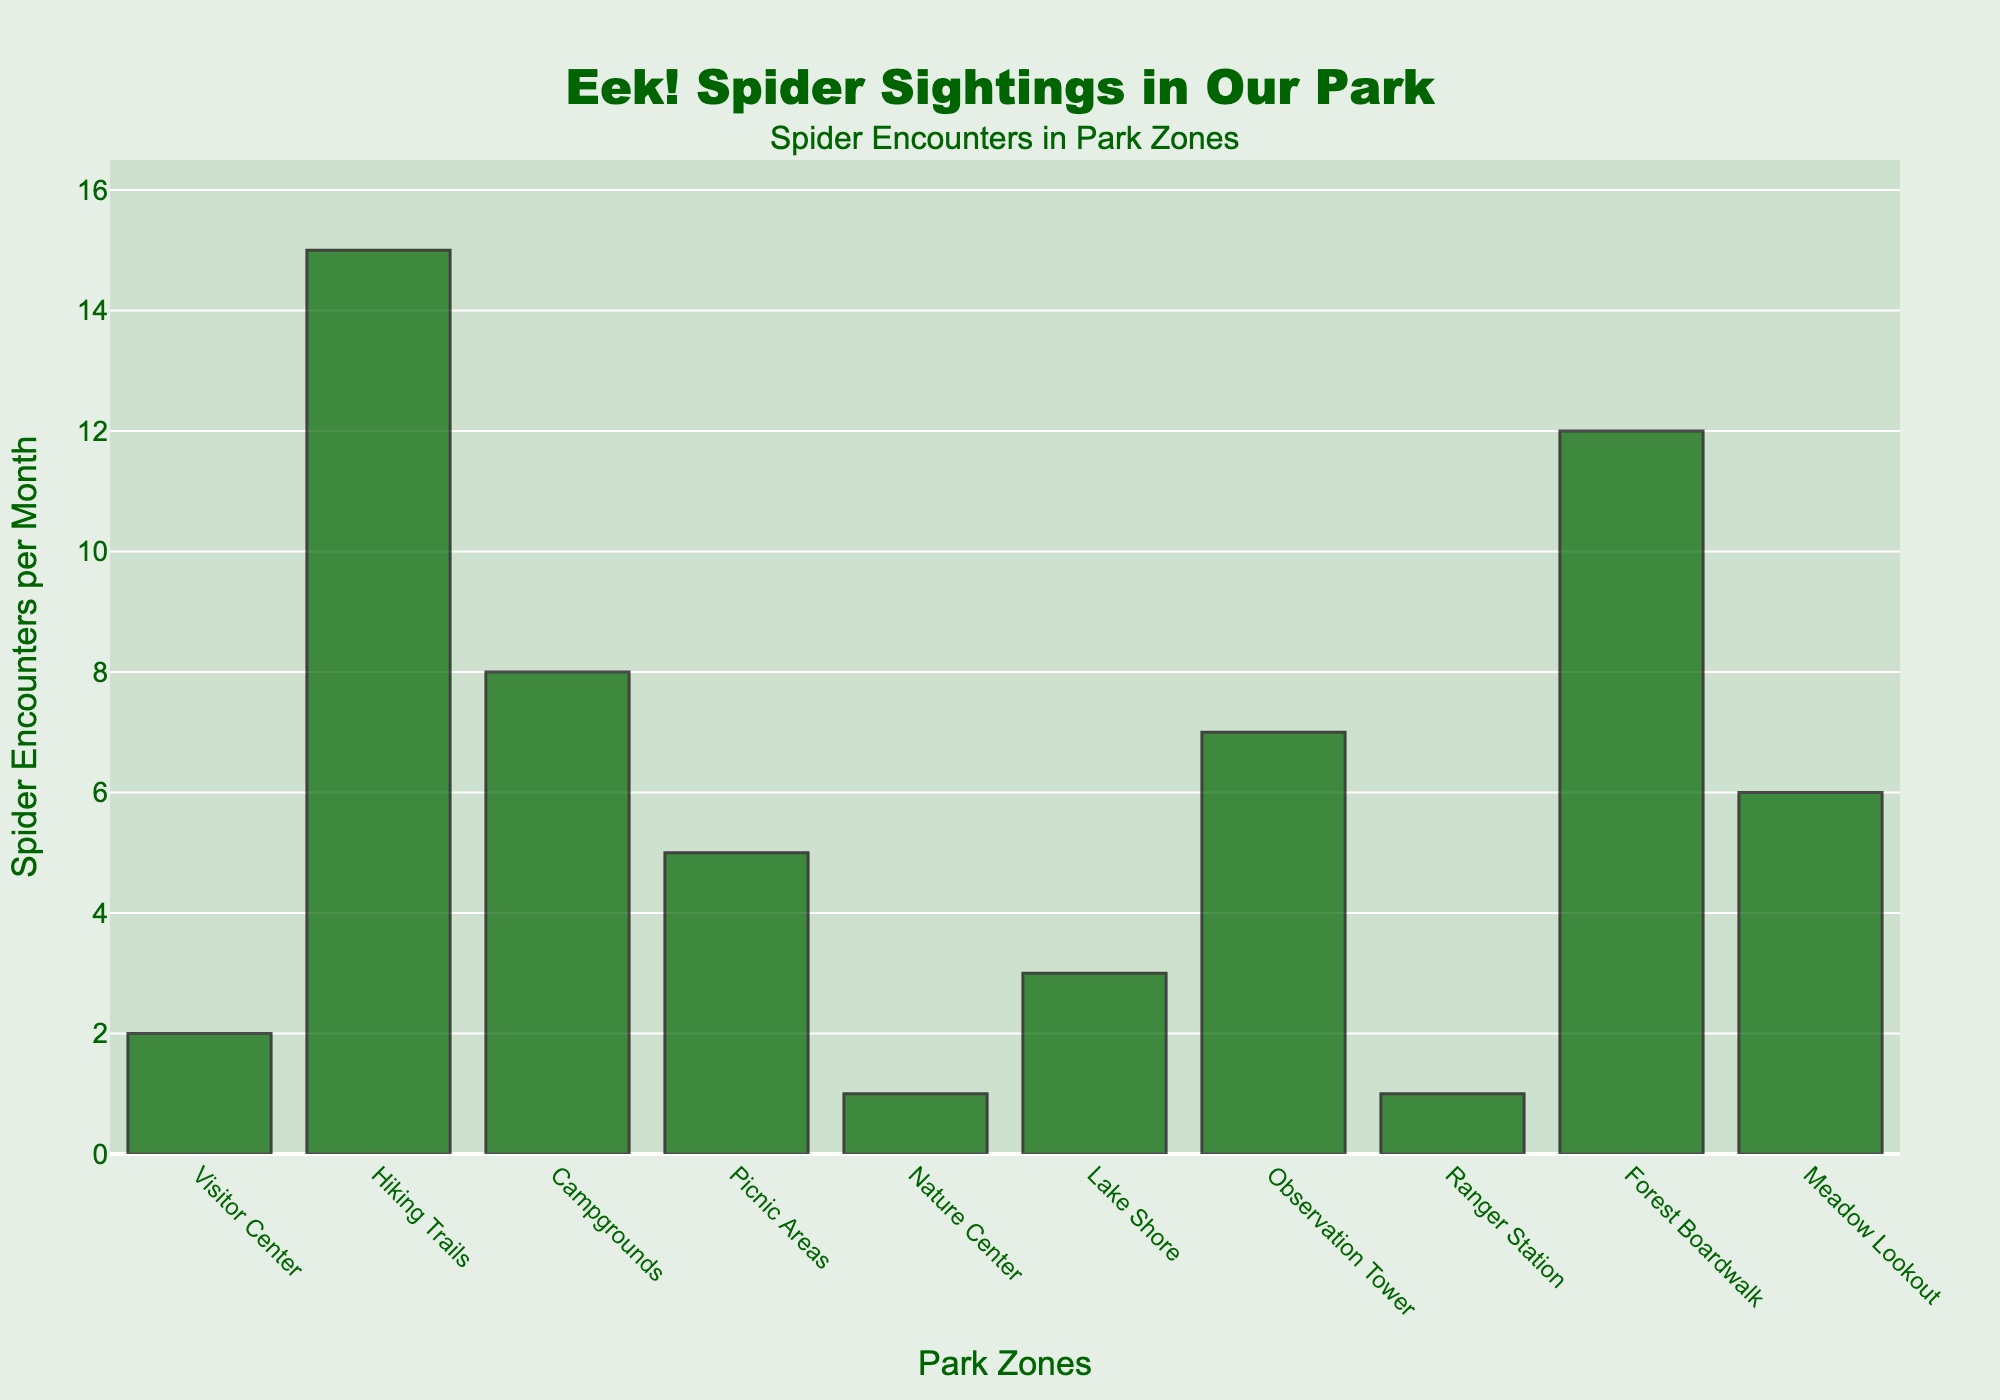Which park zone has the highest number of spider encounters per month? By looking at the height of the bars, the Hiking Trails zone has the highest bar, indicating the most spider encounters.
Answer: Hiking Trails What is the total number of spider encounters in the Visitor Center, Nature Center, and Ranger Station combined? The Visitor Center has 2 encounters, the Nature Center has 1, and the Ranger Station has 1. Adding them together: 2 + 1 + 1 = 4.
Answer: 4 How many more spider encounters are there in the Campgrounds compared to the Picnic Areas? The Campgrounds have 8 spider encounters per month and the Picnic Areas have 5. The difference is: 8 - 5 = 3.
Answer: 3 What is the average number of spider encounters per month across all park zones? First, sum up all spider encounters: 2 + 15 + 8 + 5 + 1 + 3 + 7 + 1 + 12 + 6 = 60. Divide by the number of zones (10): 60 / 10 = 6.
Answer: 6 Which zones have fewer than 5 spider encounters per month? The Visitor Center (2), Nature Center (1), Lake Shore (3), and Ranger Station (1) have fewer than 5 spider encounters.
Answer: Visitor Center, Nature Center, Lake Shore, Ranger Station How many zones have spider encounters greater than or equal to 10 per month? Count the zones with spider encounters greater than or equal to 10: Hiking Trails (15) and Forest Boardwalk (12).
Answer: 2 What is the median number of spider encounters per month? The sorted list of spider encounters is: 1, 1, 2, 3, 5, 6, 7, 8, 12, 15. With 10 data points, the middle two are 5 and 6. The median is (5 + 6) / 2 = 5.5.
Answer: 5.5 Which zone has exactly twice as many spider encounters as the Lake Shore? Lake Shore has 3 spider encounters. The zone with exactly twice that is Observation Tower (7), but the exact double would be 6.
Answer: None 